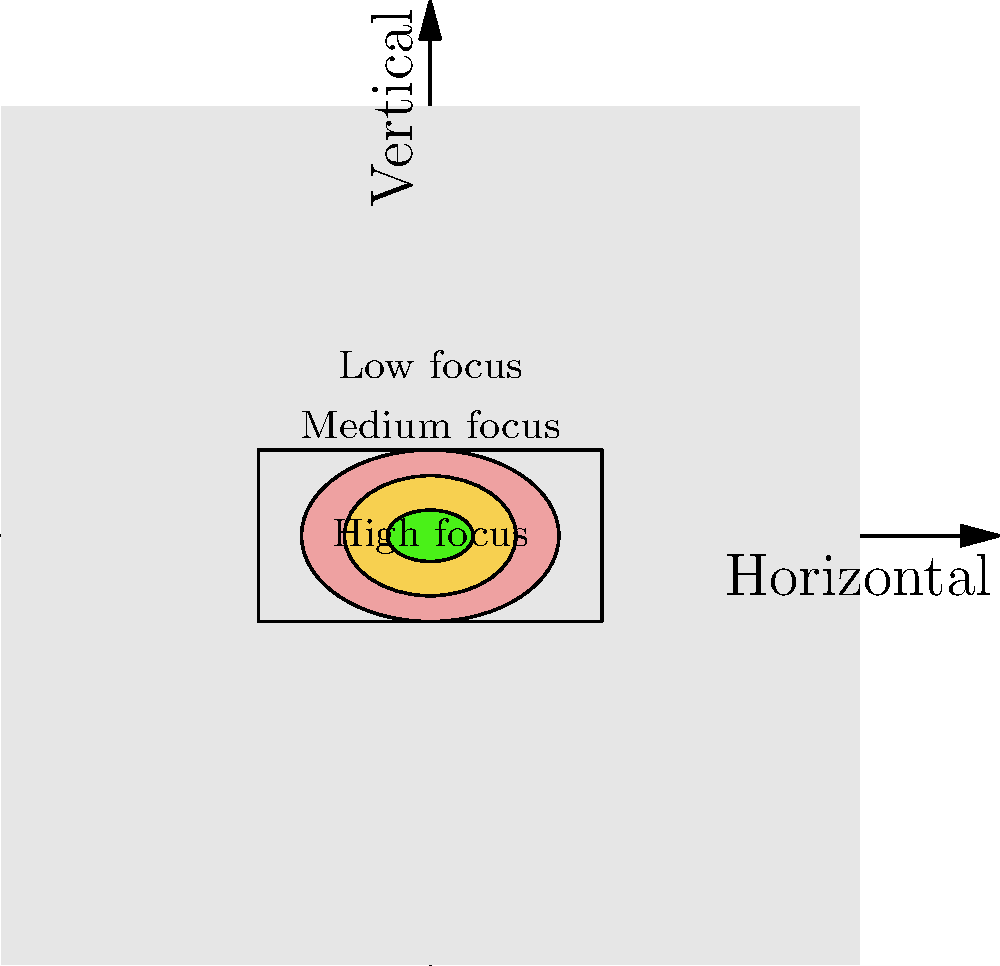Based on the visual attention heat map shown above, which area of the strike zone receives the highest focus from the catcher during pitches? To answer this question, we need to analyze the heat map provided:

1. The heat map uses different colors to represent varying levels of visual attention.
2. The map shows three concentric elliptical areas with different colors.
3. The color intensity increases towards the center of the ellipses.
4. The innermost ellipse (smallest) is colored green, which typically represents the highest intensity or focus in heat maps.
5. The middle ellipse is yellow, representing medium focus.
6. The outermost ellipse is red, representing low focus.
7. The green area is labeled "High focus" and is located at the center of the strike zone.

Therefore, based on this visual attention heat map, the area that receives the highest focus from the catcher during pitches is the center of the strike zone, represented by the small green ellipse in the middle.

This information is valuable for a sports psychologist working with catchers, as it shows where the catcher's attention is most concentrated. It can be used to develop strategies for maintaining focus on crucial areas and expanding visual awareness to other parts of the strike zone.
Answer: Center of the strike zone 